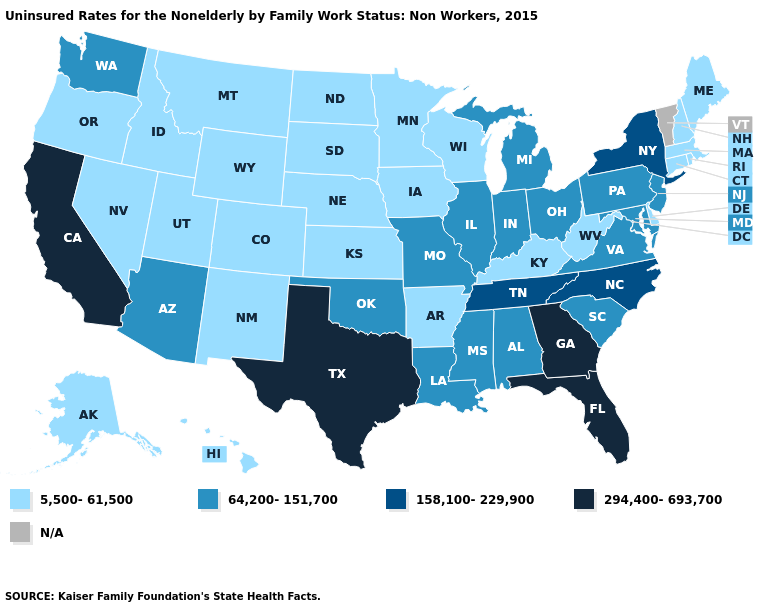Which states have the lowest value in the USA?
Keep it brief. Alaska, Arkansas, Colorado, Connecticut, Delaware, Hawaii, Idaho, Iowa, Kansas, Kentucky, Maine, Massachusetts, Minnesota, Montana, Nebraska, Nevada, New Hampshire, New Mexico, North Dakota, Oregon, Rhode Island, South Dakota, Utah, West Virginia, Wisconsin, Wyoming. Which states have the highest value in the USA?
Short answer required. California, Florida, Georgia, Texas. Name the states that have a value in the range N/A?
Keep it brief. Vermont. What is the highest value in states that border Wisconsin?
Answer briefly. 64,200-151,700. Which states have the lowest value in the MidWest?
Give a very brief answer. Iowa, Kansas, Minnesota, Nebraska, North Dakota, South Dakota, Wisconsin. What is the highest value in the Northeast ?
Keep it brief. 158,100-229,900. Name the states that have a value in the range 5,500-61,500?
Give a very brief answer. Alaska, Arkansas, Colorado, Connecticut, Delaware, Hawaii, Idaho, Iowa, Kansas, Kentucky, Maine, Massachusetts, Minnesota, Montana, Nebraska, Nevada, New Hampshire, New Mexico, North Dakota, Oregon, Rhode Island, South Dakota, Utah, West Virginia, Wisconsin, Wyoming. Among the states that border Washington , which have the lowest value?
Concise answer only. Idaho, Oregon. Does the first symbol in the legend represent the smallest category?
Answer briefly. Yes. What is the value of Mississippi?
Quick response, please. 64,200-151,700. What is the lowest value in the South?
Keep it brief. 5,500-61,500. What is the value of Massachusetts?
Quick response, please. 5,500-61,500. What is the lowest value in the South?
Give a very brief answer. 5,500-61,500. What is the lowest value in the West?
Concise answer only. 5,500-61,500. 